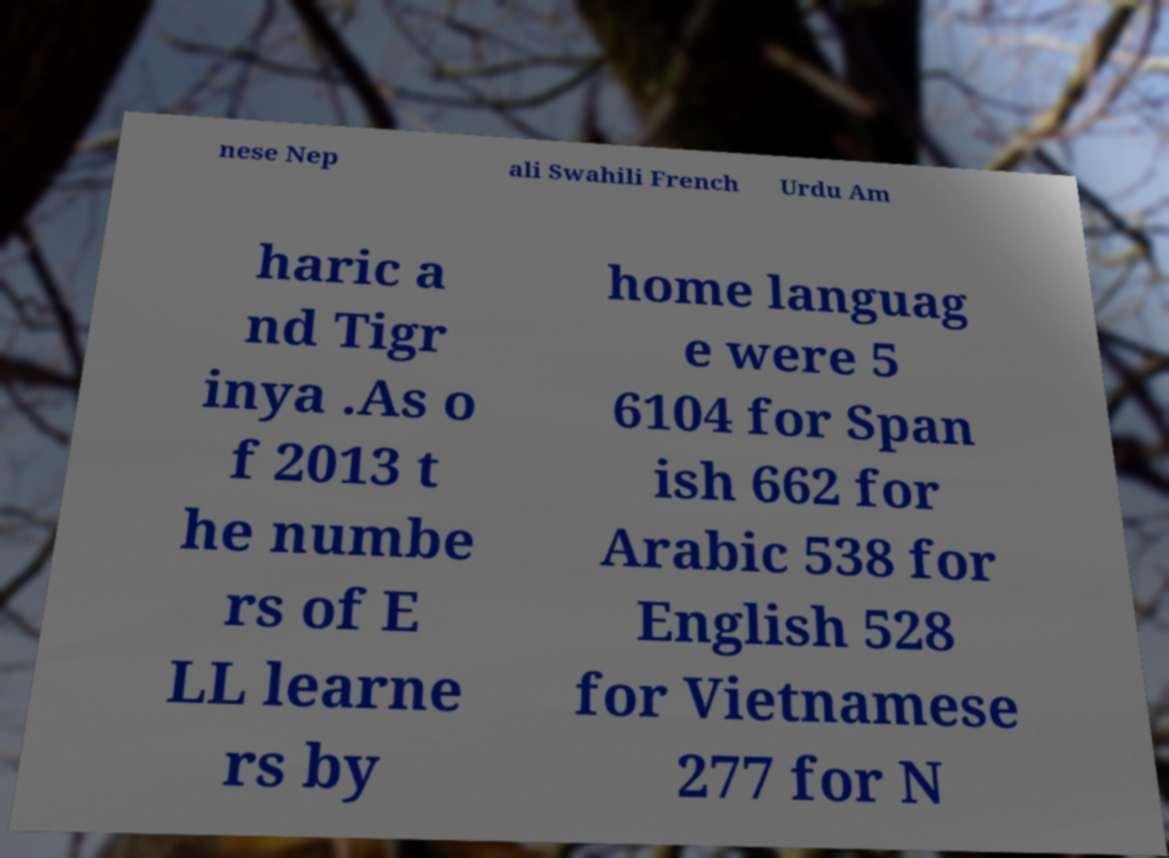Can you accurately transcribe the text from the provided image for me? nese Nep ali Swahili French Urdu Am haric a nd Tigr inya .As o f 2013 t he numbe rs of E LL learne rs by home languag e were 5 6104 for Span ish 662 for Arabic 538 for English 528 for Vietnamese 277 for N 